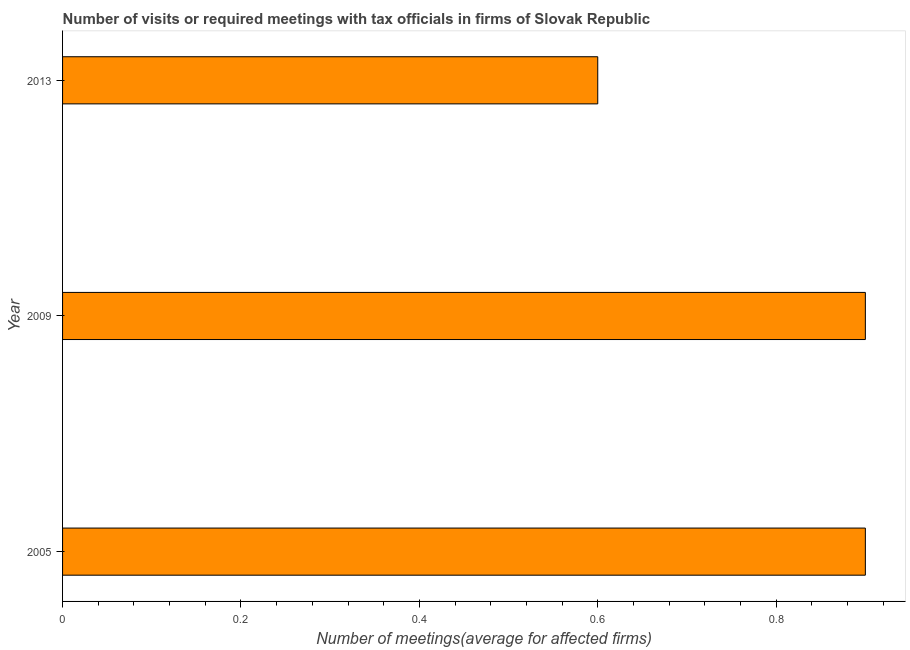What is the title of the graph?
Offer a terse response. Number of visits or required meetings with tax officials in firms of Slovak Republic. What is the label or title of the X-axis?
Keep it short and to the point. Number of meetings(average for affected firms). Across all years, what is the maximum number of required meetings with tax officials?
Your answer should be compact. 0.9. In which year was the number of required meetings with tax officials maximum?
Keep it short and to the point. 2005. Do a majority of the years between 2013 and 2005 (inclusive) have number of required meetings with tax officials greater than 0.84 ?
Your response must be concise. Yes. What is the difference between the highest and the second highest number of required meetings with tax officials?
Your response must be concise. 0. Is the sum of the number of required meetings with tax officials in 2005 and 2013 greater than the maximum number of required meetings with tax officials across all years?
Give a very brief answer. Yes. What is the difference between the highest and the lowest number of required meetings with tax officials?
Your answer should be very brief. 0.3. In how many years, is the number of required meetings with tax officials greater than the average number of required meetings with tax officials taken over all years?
Your answer should be very brief. 2. How many bars are there?
Your answer should be very brief. 3. Are all the bars in the graph horizontal?
Make the answer very short. Yes. How many years are there in the graph?
Your answer should be compact. 3. What is the difference between two consecutive major ticks on the X-axis?
Ensure brevity in your answer.  0.2. Are the values on the major ticks of X-axis written in scientific E-notation?
Offer a very short reply. No. What is the Number of meetings(average for affected firms) in 2009?
Give a very brief answer. 0.9. What is the difference between the Number of meetings(average for affected firms) in 2009 and 2013?
Your answer should be compact. 0.3. What is the ratio of the Number of meetings(average for affected firms) in 2009 to that in 2013?
Your response must be concise. 1.5. 